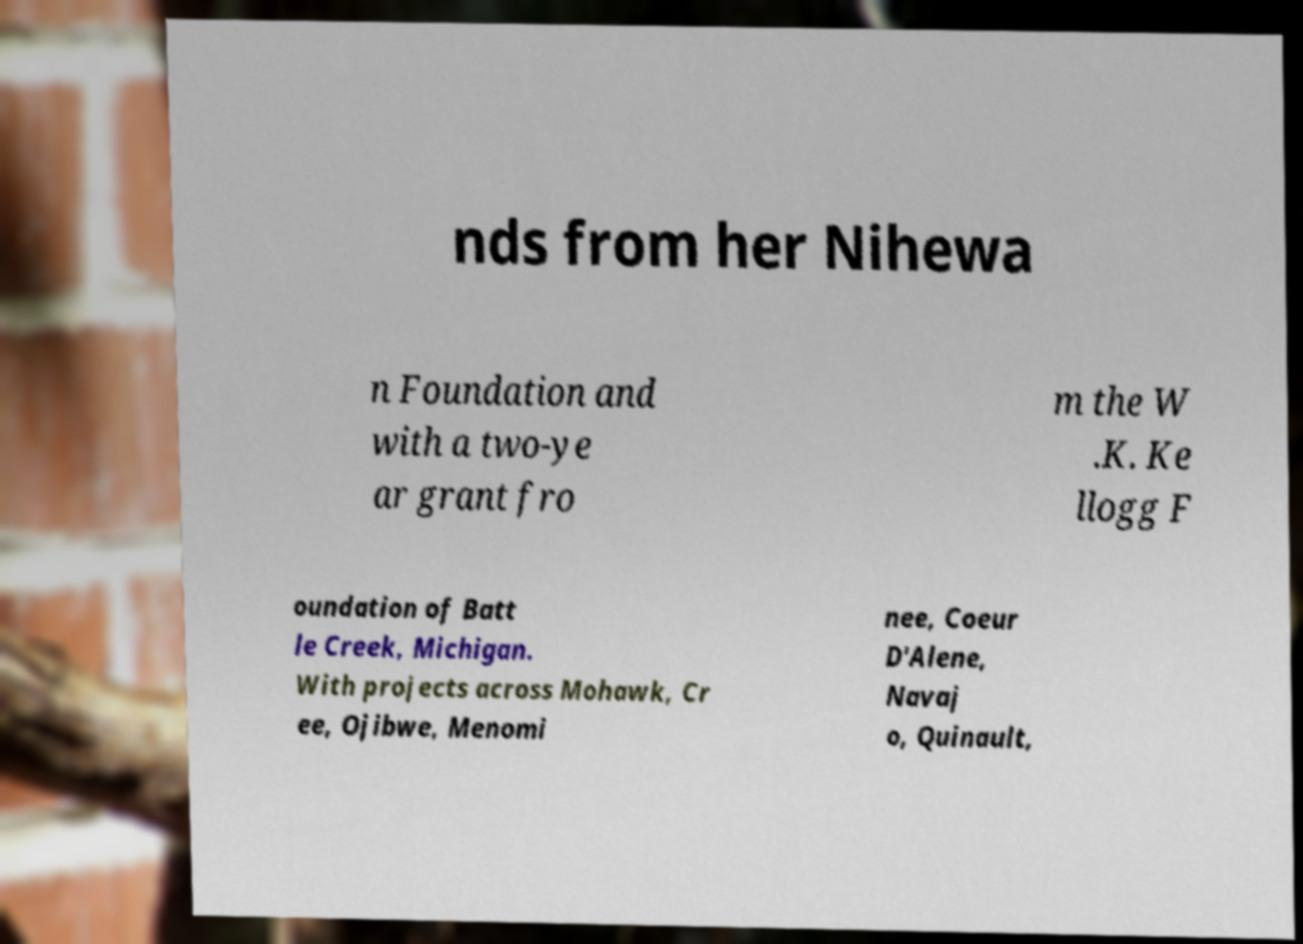Please read and relay the text visible in this image. What does it say? nds from her Nihewa n Foundation and with a two-ye ar grant fro m the W .K. Ke llogg F oundation of Batt le Creek, Michigan. With projects across Mohawk, Cr ee, Ojibwe, Menomi nee, Coeur D'Alene, Navaj o, Quinault, 